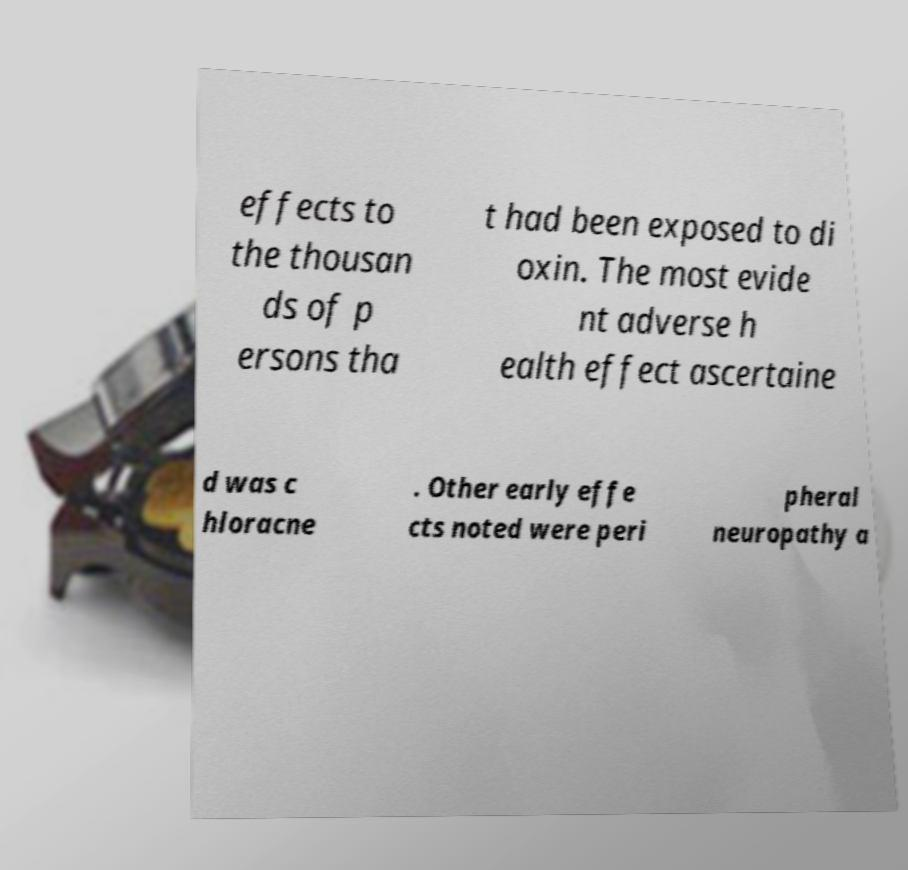Could you extract and type out the text from this image? effects to the thousan ds of p ersons tha t had been exposed to di oxin. The most evide nt adverse h ealth effect ascertaine d was c hloracne . Other early effe cts noted were peri pheral neuropathy a 